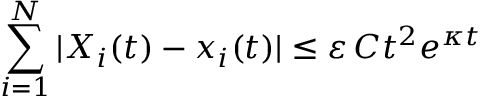<formula> <loc_0><loc_0><loc_500><loc_500>\sum _ { i = 1 } ^ { N } | X _ { i } ( t ) - x _ { i } ( t ) | \leq \varepsilon \, C t ^ { 2 } e ^ { \kappa t }</formula> 